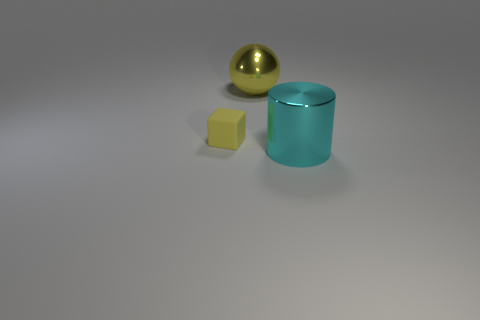Add 1 yellow matte cubes. How many objects exist? 4 Subtract all balls. How many objects are left? 2 Subtract 0 red cubes. How many objects are left? 3 Subtract all gray cubes. Subtract all red balls. How many cubes are left? 1 Subtract all green blocks. How many green spheres are left? 0 Subtract all tiny cyan balls. Subtract all yellow balls. How many objects are left? 2 Add 1 rubber things. How many rubber things are left? 2 Add 2 purple matte cylinders. How many purple matte cylinders exist? 2 